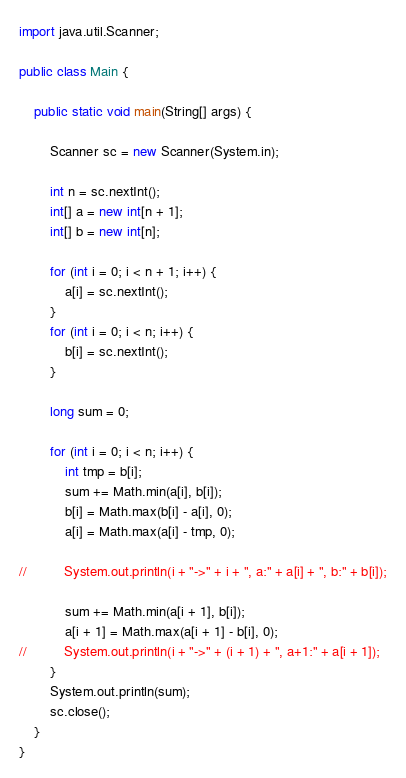<code> <loc_0><loc_0><loc_500><loc_500><_Java_>import java.util.Scanner;

public class Main {

	public static void main(String[] args) {

		Scanner sc = new Scanner(System.in);

		int n = sc.nextInt();
		int[] a = new int[n + 1];
		int[] b = new int[n];

		for (int i = 0; i < n + 1; i++) {
			a[i] = sc.nextInt();
		}
		for (int i = 0; i < n; i++) {
			b[i] = sc.nextInt();
		}

		long sum = 0;

		for (int i = 0; i < n; i++) {
			int tmp = b[i];
			sum += Math.min(a[i], b[i]);
			b[i] = Math.max(b[i] - a[i], 0);
			a[i] = Math.max(a[i] - tmp, 0);

//			System.out.println(i + "->" + i + ", a:" + a[i] + ", b:" + b[i]);

			sum += Math.min(a[i + 1], b[i]);
			a[i + 1] = Math.max(a[i + 1] - b[i], 0);
//			System.out.println(i + "->" + (i + 1) + ", a+1:" + a[i + 1]);
		}
		System.out.println(sum);
		sc.close();
	}
}</code> 